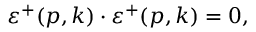Convert formula to latex. <formula><loc_0><loc_0><loc_500><loc_500>\varepsilon ^ { + } ( p , k ) \cdot \varepsilon ^ { + } ( p , k ) = 0 ,</formula> 